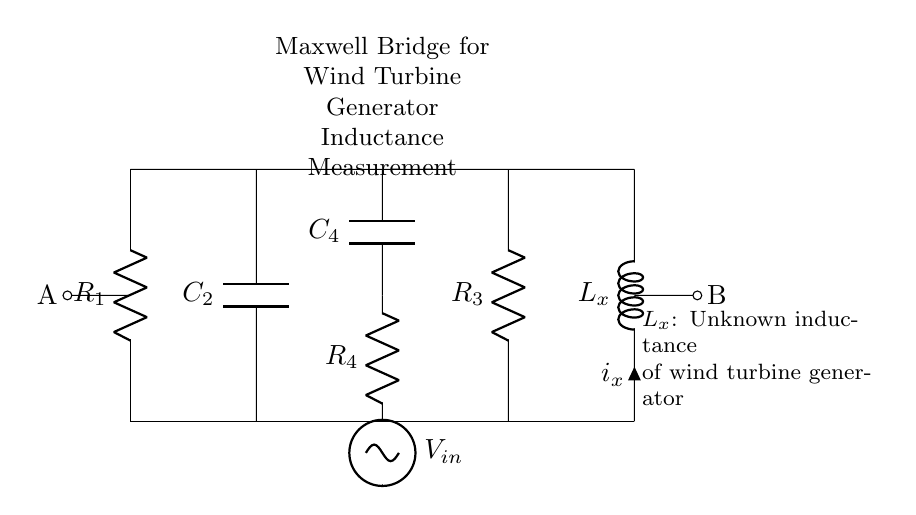What is the unknown component in this circuit? The unknown component is labeled as L_x, which indicates it is an inductor. This component is specifically used in this bridge circuit to measure inductance.
Answer: Inductor What is the function of R_1 in this circuit? R_1 is one of the resistors connected in the circuit. In a Maxwell bridge, it is used to balance the circuit and ensure that the measurements of inductance can be accurately made.
Answer: Balancing What type of circuit is this diagram representing? This is a Maxwell bridge circuit, which is specifically designed for measuring the inductance of unknown components. The inclusion of resistors and capacitors confirms its classification.
Answer: Maxwell bridge What is the role of the capacitor C_2 in this setup? Capacitor C_2 is connected in series in the bridge configuration. Its purpose is to create a phase shift in the circuit that allows for the balancing of inductance against capacitance values.
Answer: Phase shifting What point in the circuit is labeled A? Point A is marked on the left side of the diagram, indicating one of the terminals in the circuit where measurements or connections may be taken.
Answer: Left terminal What does the term "V_in" represent in this circuit? V_in represents the input voltage supplied to the Maxwell bridge circuit. It is essential for generating the conditions needed for balancing and measuring inductance accurately.
Answer: Input voltage 